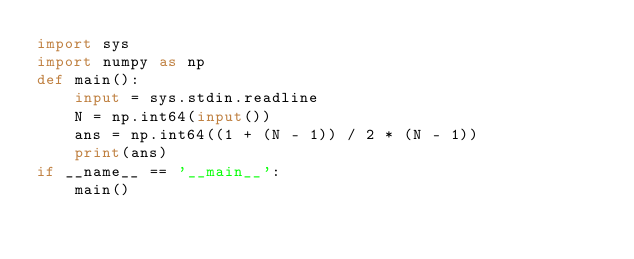Convert code to text. <code><loc_0><loc_0><loc_500><loc_500><_Python_>import sys
import numpy as np
def main():
    input = sys.stdin.readline
    N = np.int64(input())
    ans = np.int64((1 + (N - 1)) / 2 * (N - 1))
    print(ans)
if __name__ == '__main__':
    main()
</code> 